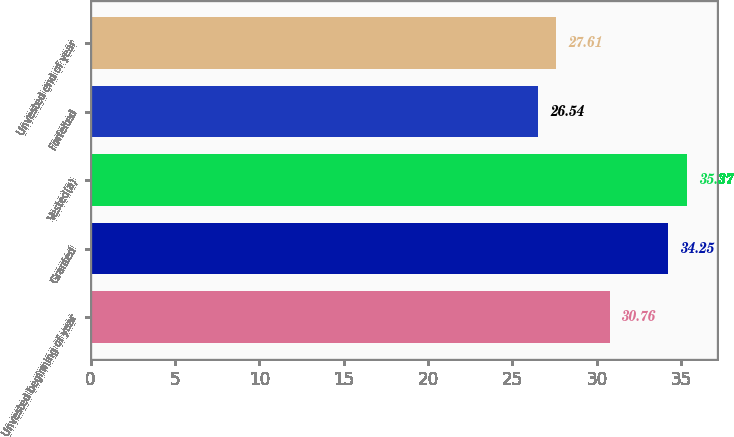Convert chart to OTSL. <chart><loc_0><loc_0><loc_500><loc_500><bar_chart><fcel>Unvested beginning of year<fcel>Granted<fcel>Vested(a)<fcel>Forfeited<fcel>Unvested end of year<nl><fcel>30.76<fcel>34.25<fcel>35.37<fcel>26.54<fcel>27.61<nl></chart> 